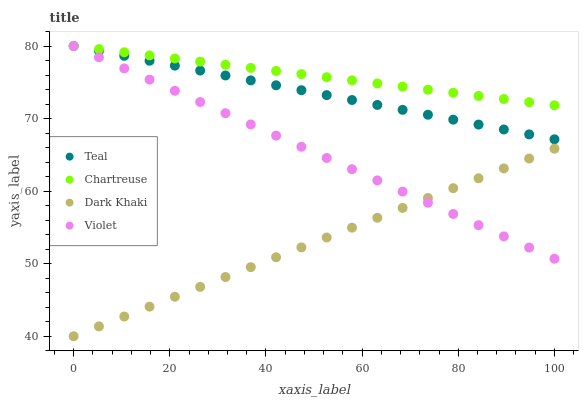Does Dark Khaki have the minimum area under the curve?
Answer yes or no. Yes. Does Chartreuse have the maximum area under the curve?
Answer yes or no. Yes. Does Teal have the minimum area under the curve?
Answer yes or no. No. Does Teal have the maximum area under the curve?
Answer yes or no. No. Is Violet the smoothest?
Answer yes or no. Yes. Is Teal the roughest?
Answer yes or no. Yes. Is Chartreuse the smoothest?
Answer yes or no. No. Is Chartreuse the roughest?
Answer yes or no. No. Does Dark Khaki have the lowest value?
Answer yes or no. Yes. Does Teal have the lowest value?
Answer yes or no. No. Does Violet have the highest value?
Answer yes or no. Yes. Is Dark Khaki less than Teal?
Answer yes or no. Yes. Is Chartreuse greater than Dark Khaki?
Answer yes or no. Yes. Does Chartreuse intersect Teal?
Answer yes or no. Yes. Is Chartreuse less than Teal?
Answer yes or no. No. Is Chartreuse greater than Teal?
Answer yes or no. No. Does Dark Khaki intersect Teal?
Answer yes or no. No. 